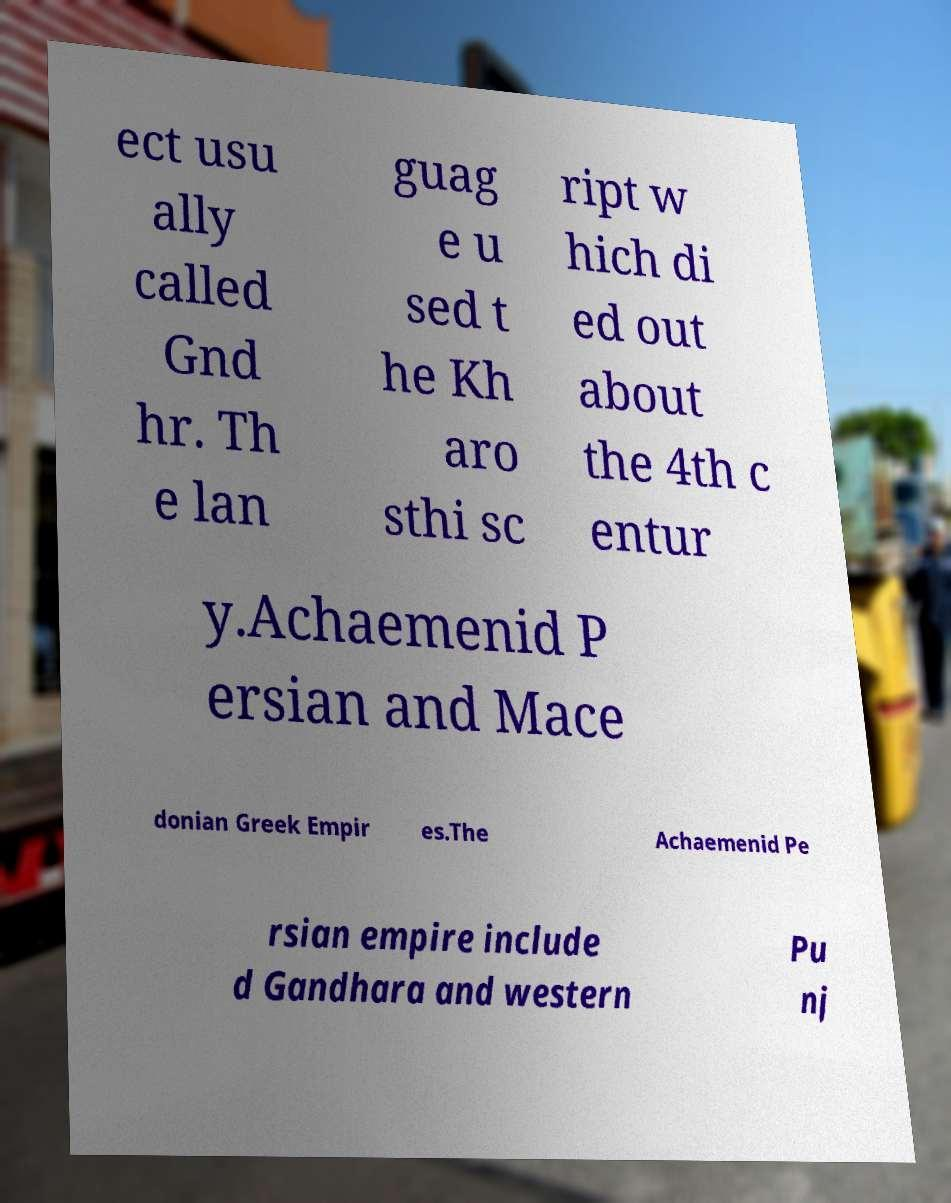I need the written content from this picture converted into text. Can you do that? ect usu ally called Gnd hr. Th e lan guag e u sed t he Kh aro sthi sc ript w hich di ed out about the 4th c entur y.Achaemenid P ersian and Mace donian Greek Empir es.The Achaemenid Pe rsian empire include d Gandhara and western Pu nj 